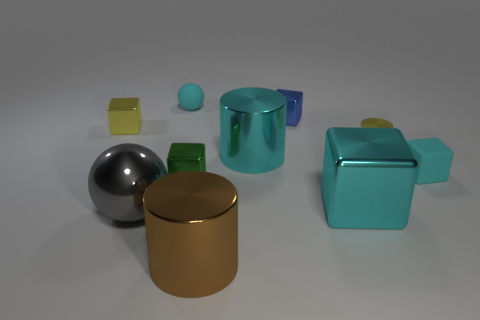Subtract all small yellow blocks. How many blocks are left? 4 Subtract all yellow spheres. How many cyan blocks are left? 2 Subtract all yellow cubes. How many cubes are left? 4 Subtract 1 cubes. How many cubes are left? 4 Subtract all gray cylinders. Subtract all green spheres. How many cylinders are left? 3 Subtract all spheres. How many objects are left? 8 Subtract 0 purple cubes. How many objects are left? 10 Subtract all big blue balls. Subtract all gray things. How many objects are left? 9 Add 5 green blocks. How many green blocks are left? 6 Add 7 big green shiny cylinders. How many big green shiny cylinders exist? 7 